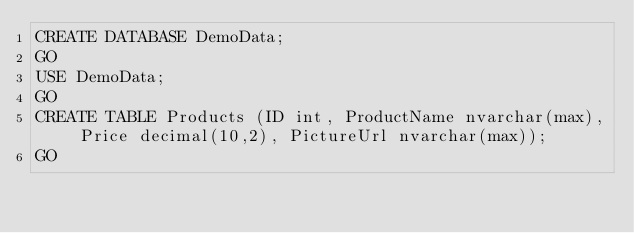<code> <loc_0><loc_0><loc_500><loc_500><_SQL_>CREATE DATABASE DemoData;
GO
USE DemoData;
GO
CREATE TABLE Products (ID int, ProductName nvarchar(max), Price decimal(10,2), PictureUrl nvarchar(max));
GO</code> 